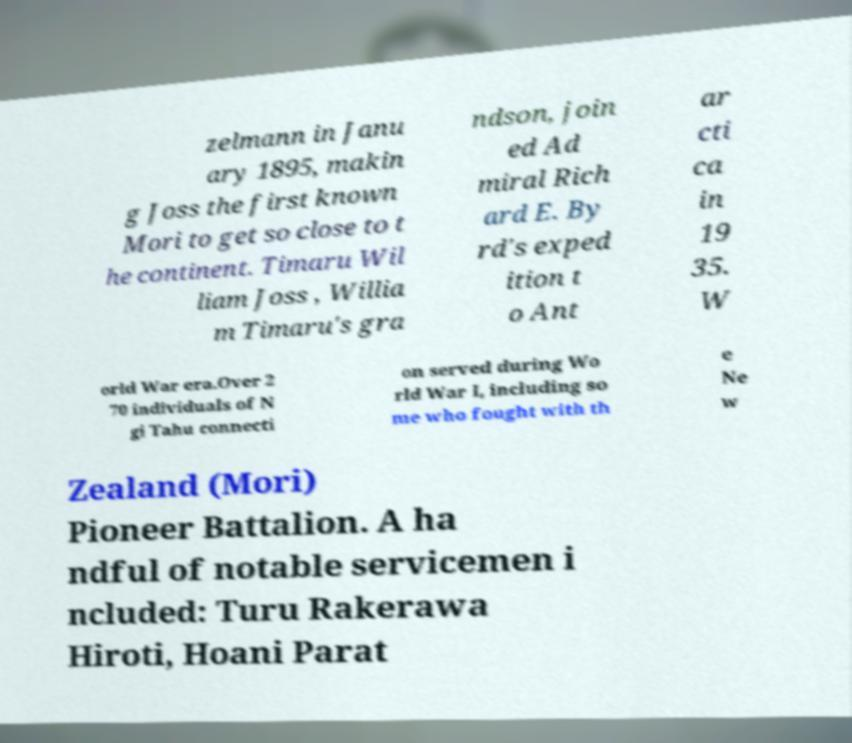Can you read and provide the text displayed in the image?This photo seems to have some interesting text. Can you extract and type it out for me? zelmann in Janu ary 1895, makin g Joss the first known Mori to get so close to t he continent. Timaru Wil liam Joss , Willia m Timaru's gra ndson, join ed Ad miral Rich ard E. By rd's exped ition t o Ant ar cti ca in 19 35. W orld War era.Over 2 70 individuals of N gi Tahu connecti on served during Wo rld War I, including so me who fought with th e Ne w Zealand (Mori) Pioneer Battalion. A ha ndful of notable servicemen i ncluded: Turu Rakerawa Hiroti, Hoani Parat 